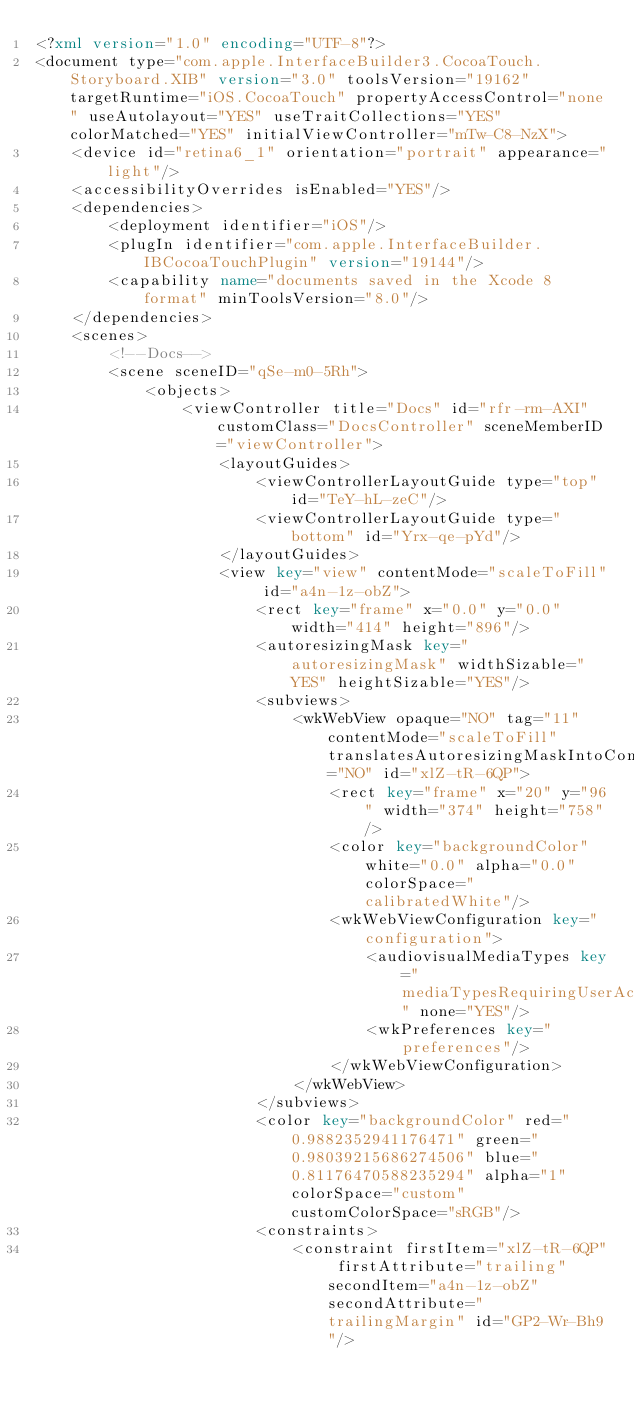<code> <loc_0><loc_0><loc_500><loc_500><_XML_><?xml version="1.0" encoding="UTF-8"?>
<document type="com.apple.InterfaceBuilder3.CocoaTouch.Storyboard.XIB" version="3.0" toolsVersion="19162" targetRuntime="iOS.CocoaTouch" propertyAccessControl="none" useAutolayout="YES" useTraitCollections="YES" colorMatched="YES" initialViewController="mTw-C8-NzX">
    <device id="retina6_1" orientation="portrait" appearance="light"/>
    <accessibilityOverrides isEnabled="YES"/>
    <dependencies>
        <deployment identifier="iOS"/>
        <plugIn identifier="com.apple.InterfaceBuilder.IBCocoaTouchPlugin" version="19144"/>
        <capability name="documents saved in the Xcode 8 format" minToolsVersion="8.0"/>
    </dependencies>
    <scenes>
        <!--Docs-->
        <scene sceneID="qSe-m0-5Rh">
            <objects>
                <viewController title="Docs" id="rfr-rm-AXI" customClass="DocsController" sceneMemberID="viewController">
                    <layoutGuides>
                        <viewControllerLayoutGuide type="top" id="TeY-hL-zeC"/>
                        <viewControllerLayoutGuide type="bottom" id="Yrx-qe-pYd"/>
                    </layoutGuides>
                    <view key="view" contentMode="scaleToFill" id="a4n-1z-obZ">
                        <rect key="frame" x="0.0" y="0.0" width="414" height="896"/>
                        <autoresizingMask key="autoresizingMask" widthSizable="YES" heightSizable="YES"/>
                        <subviews>
                            <wkWebView opaque="NO" tag="11" contentMode="scaleToFill" translatesAutoresizingMaskIntoConstraints="NO" id="xlZ-tR-6QP">
                                <rect key="frame" x="20" y="96" width="374" height="758"/>
                                <color key="backgroundColor" white="0.0" alpha="0.0" colorSpace="calibratedWhite"/>
                                <wkWebViewConfiguration key="configuration">
                                    <audiovisualMediaTypes key="mediaTypesRequiringUserActionForPlayback" none="YES"/>
                                    <wkPreferences key="preferences"/>
                                </wkWebViewConfiguration>
                            </wkWebView>
                        </subviews>
                        <color key="backgroundColor" red="0.9882352941176471" green="0.98039215686274506" blue="0.81176470588235294" alpha="1" colorSpace="custom" customColorSpace="sRGB"/>
                        <constraints>
                            <constraint firstItem="xlZ-tR-6QP" firstAttribute="trailing" secondItem="a4n-1z-obZ" secondAttribute="trailingMargin" id="GP2-Wr-Bh9"/></code> 